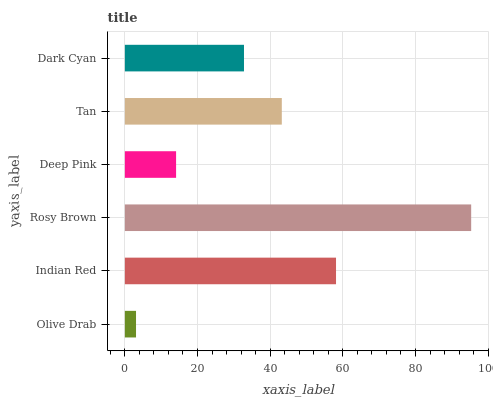Is Olive Drab the minimum?
Answer yes or no. Yes. Is Rosy Brown the maximum?
Answer yes or no. Yes. Is Indian Red the minimum?
Answer yes or no. No. Is Indian Red the maximum?
Answer yes or no. No. Is Indian Red greater than Olive Drab?
Answer yes or no. Yes. Is Olive Drab less than Indian Red?
Answer yes or no. Yes. Is Olive Drab greater than Indian Red?
Answer yes or no. No. Is Indian Red less than Olive Drab?
Answer yes or no. No. Is Tan the high median?
Answer yes or no. Yes. Is Dark Cyan the low median?
Answer yes or no. Yes. Is Olive Drab the high median?
Answer yes or no. No. Is Indian Red the low median?
Answer yes or no. No. 